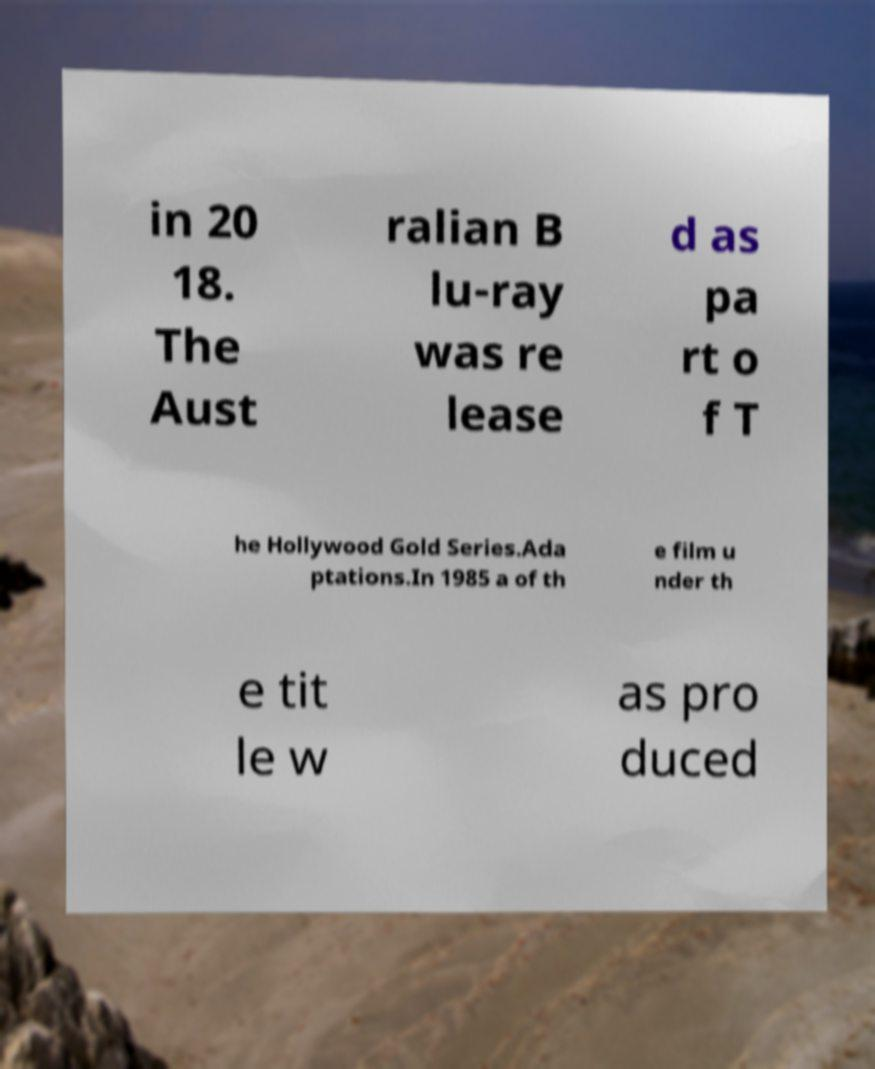Can you read and provide the text displayed in the image?This photo seems to have some interesting text. Can you extract and type it out for me? in 20 18. The Aust ralian B lu-ray was re lease d as pa rt o f T he Hollywood Gold Series.Ada ptations.In 1985 a of th e film u nder th e tit le w as pro duced 